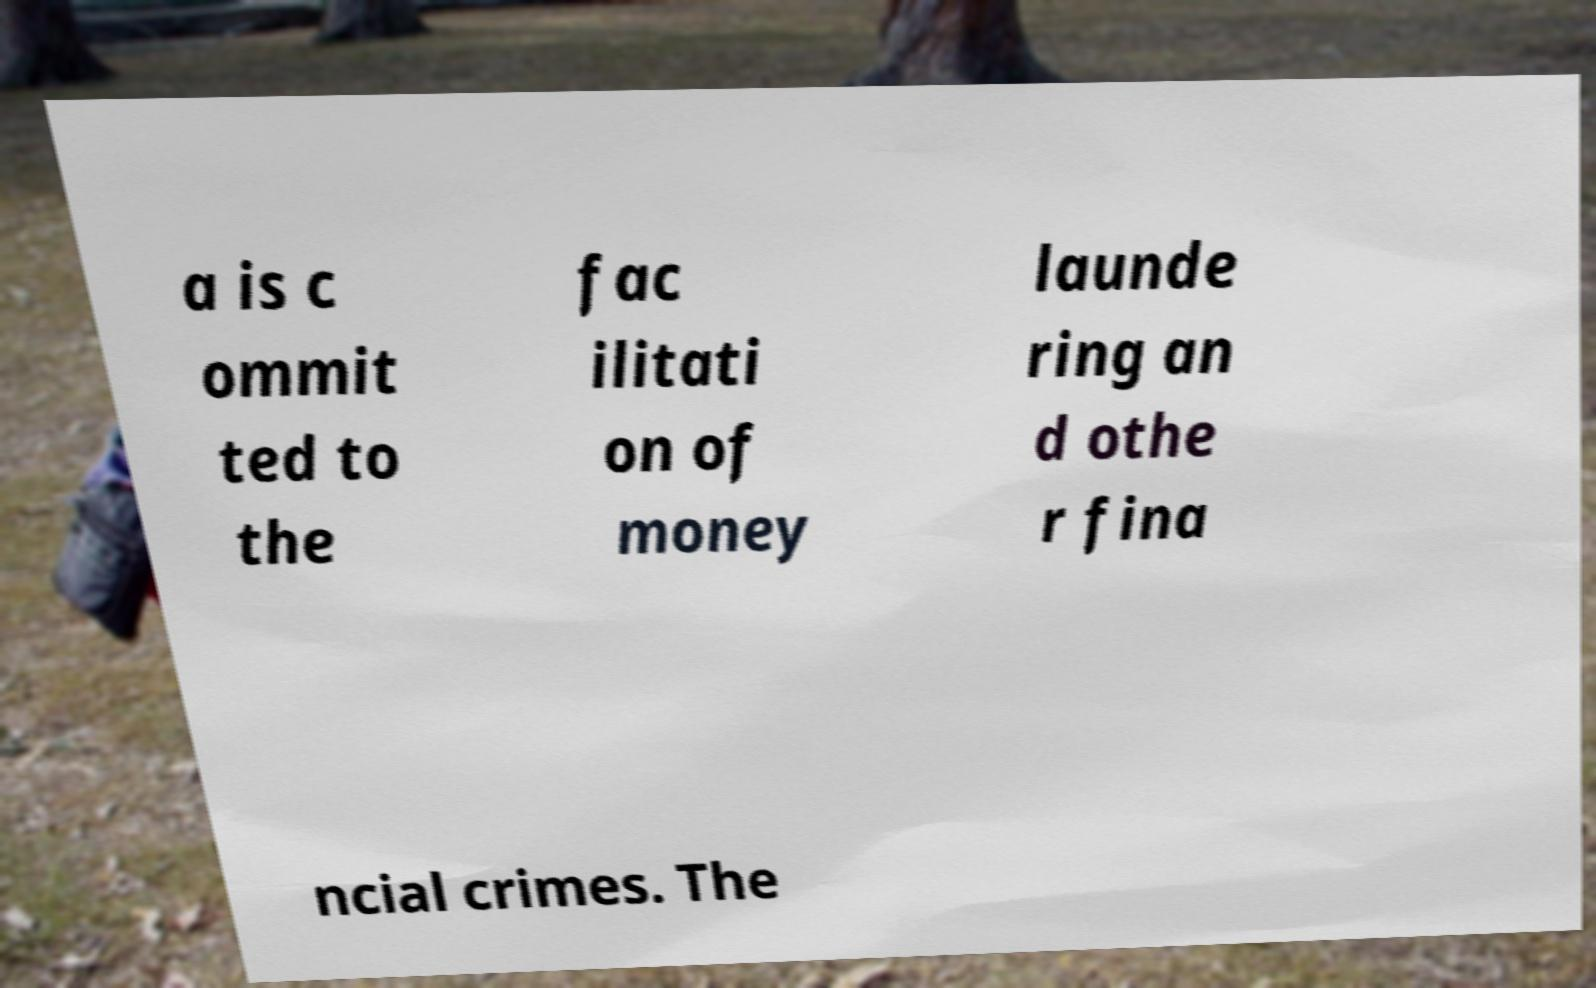Can you read and provide the text displayed in the image?This photo seems to have some interesting text. Can you extract and type it out for me? a is c ommit ted to the fac ilitati on of money launde ring an d othe r fina ncial crimes. The 